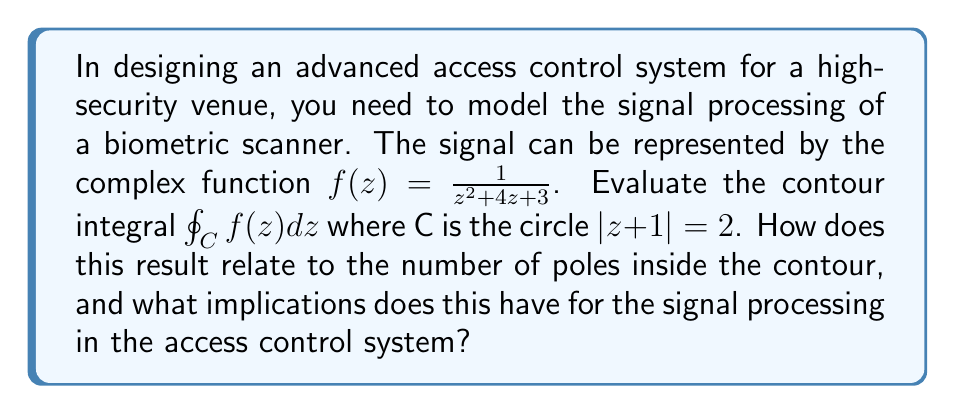Help me with this question. To evaluate this contour integral, we'll use the Residue Theorem. Let's approach this step-by-step:

1) First, we need to find the poles of $f(z)$. The denominator of $f(z)$ is $z^2 + 4z + 3$, which can be factored as $(z+3)(z+1)$. So, the poles are at $z=-3$ and $z=-1$.

2) The contour C is described by $|z+1| = 2$. This is a circle centered at $-1$ with radius 2.

3) We need to determine which poles are inside this contour. The pole at $z=-1$ is at the center of the circle, so it's inside. The pole at $z=-3$ is outside the circle.

4) Now we can apply the Residue Theorem:

   $$\oint_C f(z) dz = 2\pi i \sum \text{Res}(f, a_k)$$

   where $a_k$ are the poles inside C.

5) We only need to calculate the residue at $z=-1$. Since this is a simple pole, we can use the formula:

   $$\text{Res}(f, -1) = \lim_{z \to -1} (z+1)f(z) = \lim_{z \to -1} \frac{z+1}{z^2 + 4z + 3} = \lim_{z \to -1} \frac{1}{z+3} = \frac{1}{2}$$

6) Applying the Residue Theorem:

   $$\oint_C f(z) dz = 2\pi i \cdot \frac{1}{2} = \pi i$$

This result shows that the integral is equal to $\pi i$ times the number of poles inside the contour (which is 1 in this case).

For signal processing in access control systems, this result has several implications:

1) The number of poles inside the contour relates to the number of significant features in the frequency domain of the signal.
2) The value of the integral provides information about the phase and magnitude response of the system at specific frequencies.
3) This analysis can help in designing filters to process the biometric signals more effectively, improving the accuracy and reliability of the access control system.
Answer: $$\oint_C f(z) dz = \pi i$$ 